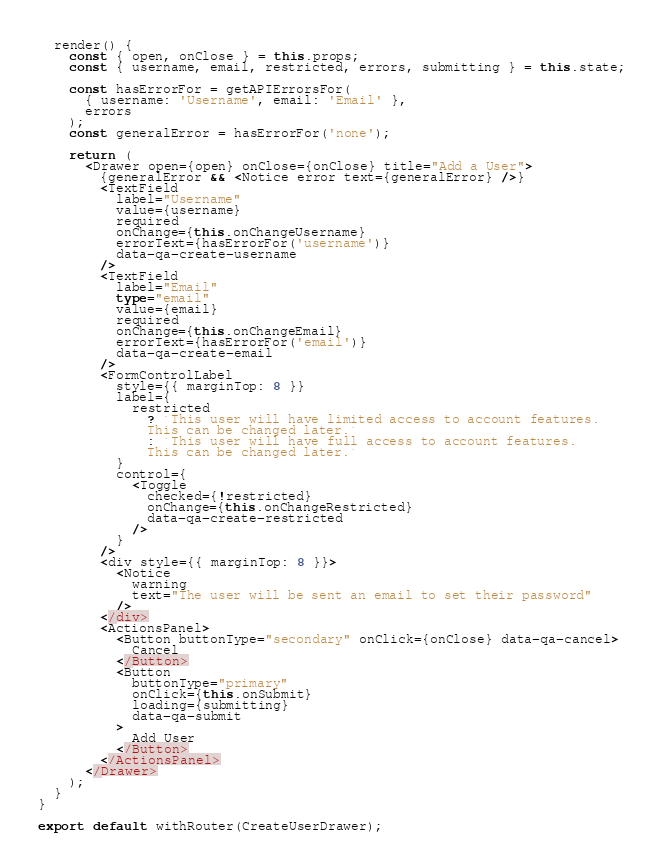<code> <loc_0><loc_0><loc_500><loc_500><_TypeScript_>  render() {
    const { open, onClose } = this.props;
    const { username, email, restricted, errors, submitting } = this.state;

    const hasErrorFor = getAPIErrorsFor(
      { username: 'Username', email: 'Email' },
      errors
    );
    const generalError = hasErrorFor('none');

    return (
      <Drawer open={open} onClose={onClose} title="Add a User">
        {generalError && <Notice error text={generalError} />}
        <TextField
          label="Username"
          value={username}
          required
          onChange={this.onChangeUsername}
          errorText={hasErrorFor('username')}
          data-qa-create-username
        />
        <TextField
          label="Email"
          type="email"
          value={email}
          required
          onChange={this.onChangeEmail}
          errorText={hasErrorFor('email')}
          data-qa-create-email
        />
        <FormControlLabel
          style={{ marginTop: 8 }}
          label={
            restricted
              ? `This user will have limited access to account features.
              This can be changed later.`
              : `This user will have full access to account features.
              This can be changed later.`
          }
          control={
            <Toggle
              checked={!restricted}
              onChange={this.onChangeRestricted}
              data-qa-create-restricted
            />
          }
        />
        <div style={{ marginTop: 8 }}>
          <Notice
            warning
            text="The user will be sent an email to set their password"
          />
        </div>
        <ActionsPanel>
          <Button buttonType="secondary" onClick={onClose} data-qa-cancel>
            Cancel
          </Button>
          <Button
            buttonType="primary"
            onClick={this.onSubmit}
            loading={submitting}
            data-qa-submit
          >
            Add User
          </Button>
        </ActionsPanel>
      </Drawer>
    );
  }
}

export default withRouter(CreateUserDrawer);
</code> 